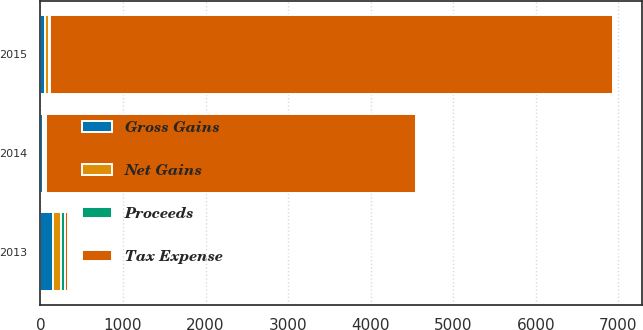<chart> <loc_0><loc_0><loc_500><loc_500><stacked_bar_chart><ecel><fcel>2015<fcel>2014<fcel>2013<nl><fcel>Tax Expense<fcel>6829<fcel>4480<fcel>47<nl><fcel>Gross Gains<fcel>56<fcel>33<fcel>146<nl><fcel>Proceeds<fcel>13<fcel>29<fcel>47<nl><fcel>Net Gains<fcel>43<fcel>4<fcel>99<nl></chart> 